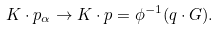Convert formula to latex. <formula><loc_0><loc_0><loc_500><loc_500>K \cdot p _ { \alpha } \to K \cdot p = \phi ^ { - 1 } ( q \cdot G ) .</formula> 